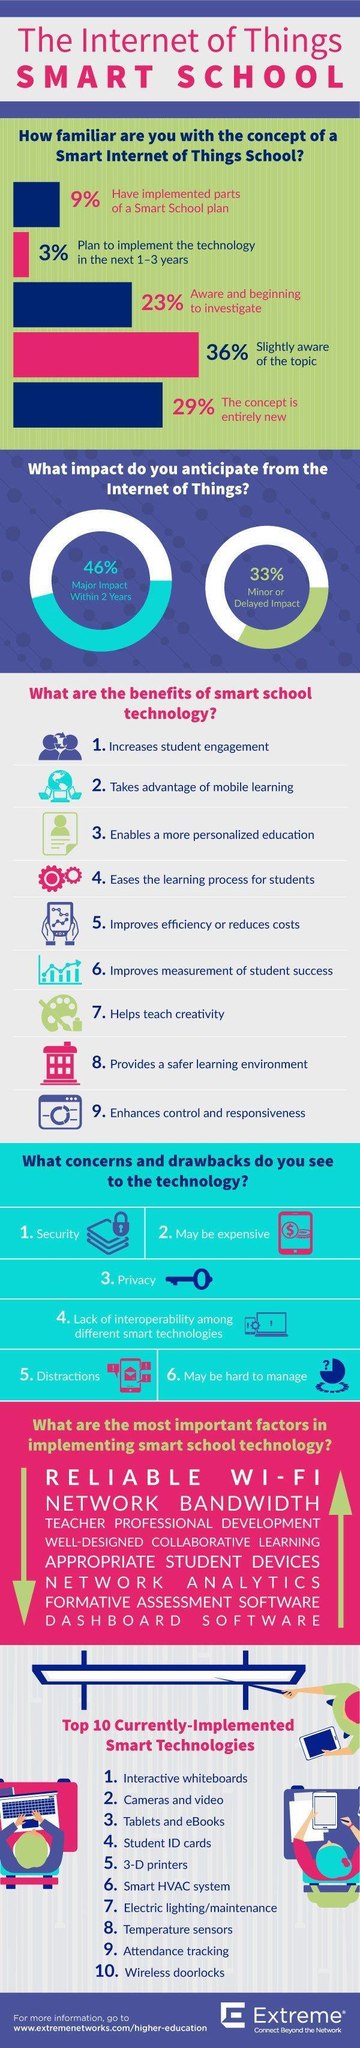WHat is the total % who have either implemented or plan to implement the technology in the next 1-3 years
Answer the question with a short phrase. 12 WHat concern is indicated by the key image privacy What % feel a minor or delayed impact from the internet of things 33% WHat technology can be used to monitor the control the temperature and lighting Smart HVAC system, Electric lighting/maintenance, temperature sensors What benefit does the bar chart indicate improves measurement of student success What benefit does the paint brush and colouring palette indicate Helps teach creativity WHat % are not aware of the concept of Smart Internet of Things School 29% in smart technology, what type of board is the tutor pointing at interactive whiteboards 